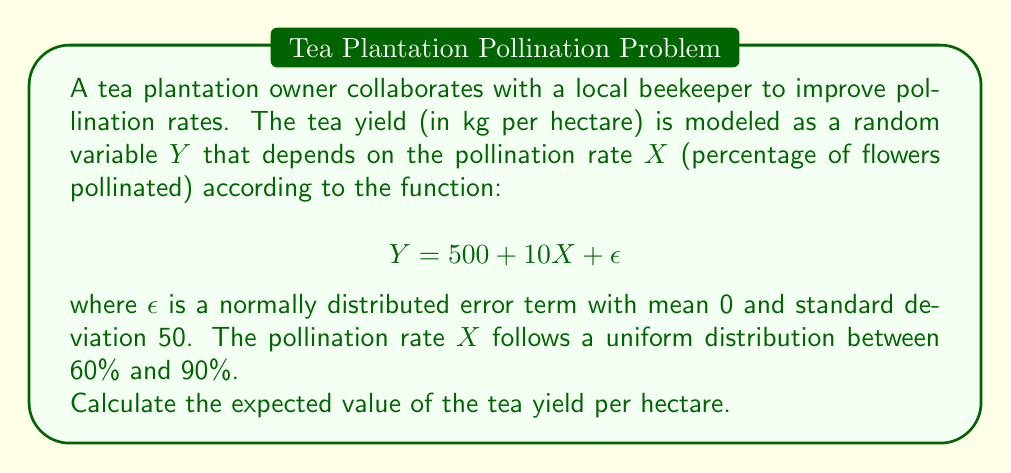Show me your answer to this math problem. To solve this problem, we'll follow these steps:

1) First, we need to find $E[X]$, the expected value of the pollination rate:
   For a uniform distribution between $a$ and $b$, $E[X] = \frac{a+b}{2}$
   $$E[X] = \frac{60 + 90}{2} = 75\%$$

2) Now, we can use the linearity of expectation:
   $$E[Y] = E[500 + 10X + \epsilon]$$
   $$E[Y] = E[500] + E[10X] + E[\epsilon]$$

3) We know that:
   - $E[500] = 500$ (constant)
   - $E[10X] = 10E[X] = 10 \cdot 75 = 750$ (linearity of expectation)
   - $E[\epsilon] = 0$ (given in the problem)

4) Substituting these values:
   $$E[Y] = 500 + 750 + 0 = 1250$$

Therefore, the expected value of the tea yield is 1250 kg per hectare.
Answer: 1250 kg/hectare 